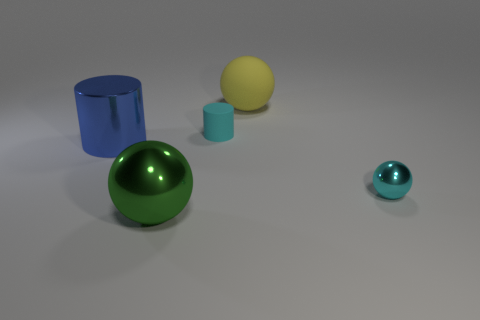There is a cylinder that is the same size as the yellow ball; what is its color?
Your response must be concise. Blue. Are there any other matte spheres of the same color as the small ball?
Provide a short and direct response. No. Are any tiny gray cylinders visible?
Offer a terse response. No. There is a small thing behind the large blue thing; what shape is it?
Ensure brevity in your answer.  Cylinder. How many things are both on the right side of the big green metallic object and behind the small ball?
Give a very brief answer. 2. What number of other objects are there of the same size as the cyan shiny ball?
Your answer should be compact. 1. Does the tiny cyan thing to the right of the large yellow rubber ball have the same shape as the large object right of the large green thing?
Keep it short and to the point. Yes. What number of things are yellow rubber spheres or large spheres in front of the blue object?
Make the answer very short. 2. What is the material of the sphere that is in front of the big yellow rubber sphere and to the right of the small cyan cylinder?
Provide a succinct answer. Metal. What color is the tiny thing that is the same material as the yellow sphere?
Your answer should be very brief. Cyan. 